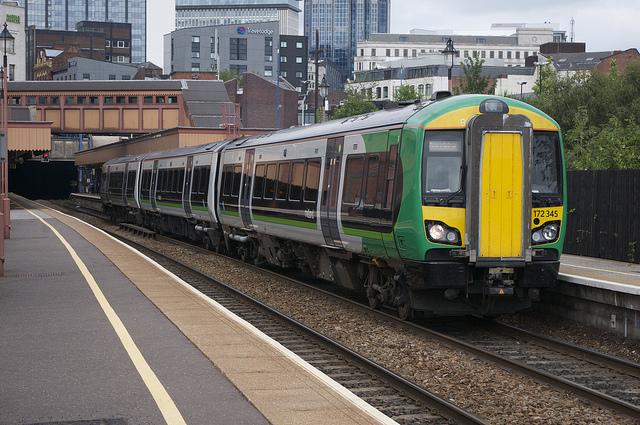What is this vehicle?
Short answer required. Train. What country's flag does the colors of the train resemble?
Answer briefly. Jamaica. What color is the front of the train?
Concise answer only. Yellow. Are there clouds reflecting on the building in the background?
Answer briefly. No. Is there much litter?
Short answer required. No. Why is the train green?
Write a very short answer. Company colors. How many buildings are in the background?
Be succinct. 15. 